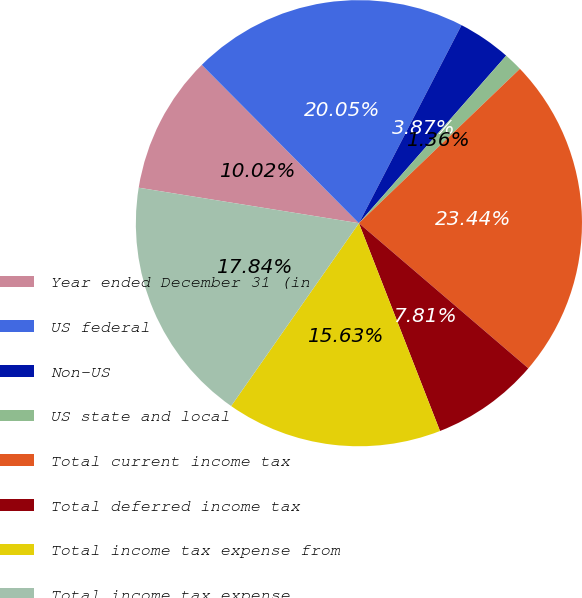Convert chart to OTSL. <chart><loc_0><loc_0><loc_500><loc_500><pie_chart><fcel>Year ended December 31 (in<fcel>US federal<fcel>Non-US<fcel>US state and local<fcel>Total current income tax<fcel>Total deferred income tax<fcel>Total income tax expense from<fcel>Total income tax expense<nl><fcel>10.02%<fcel>20.05%<fcel>3.87%<fcel>1.36%<fcel>23.44%<fcel>7.81%<fcel>15.63%<fcel>17.84%<nl></chart> 